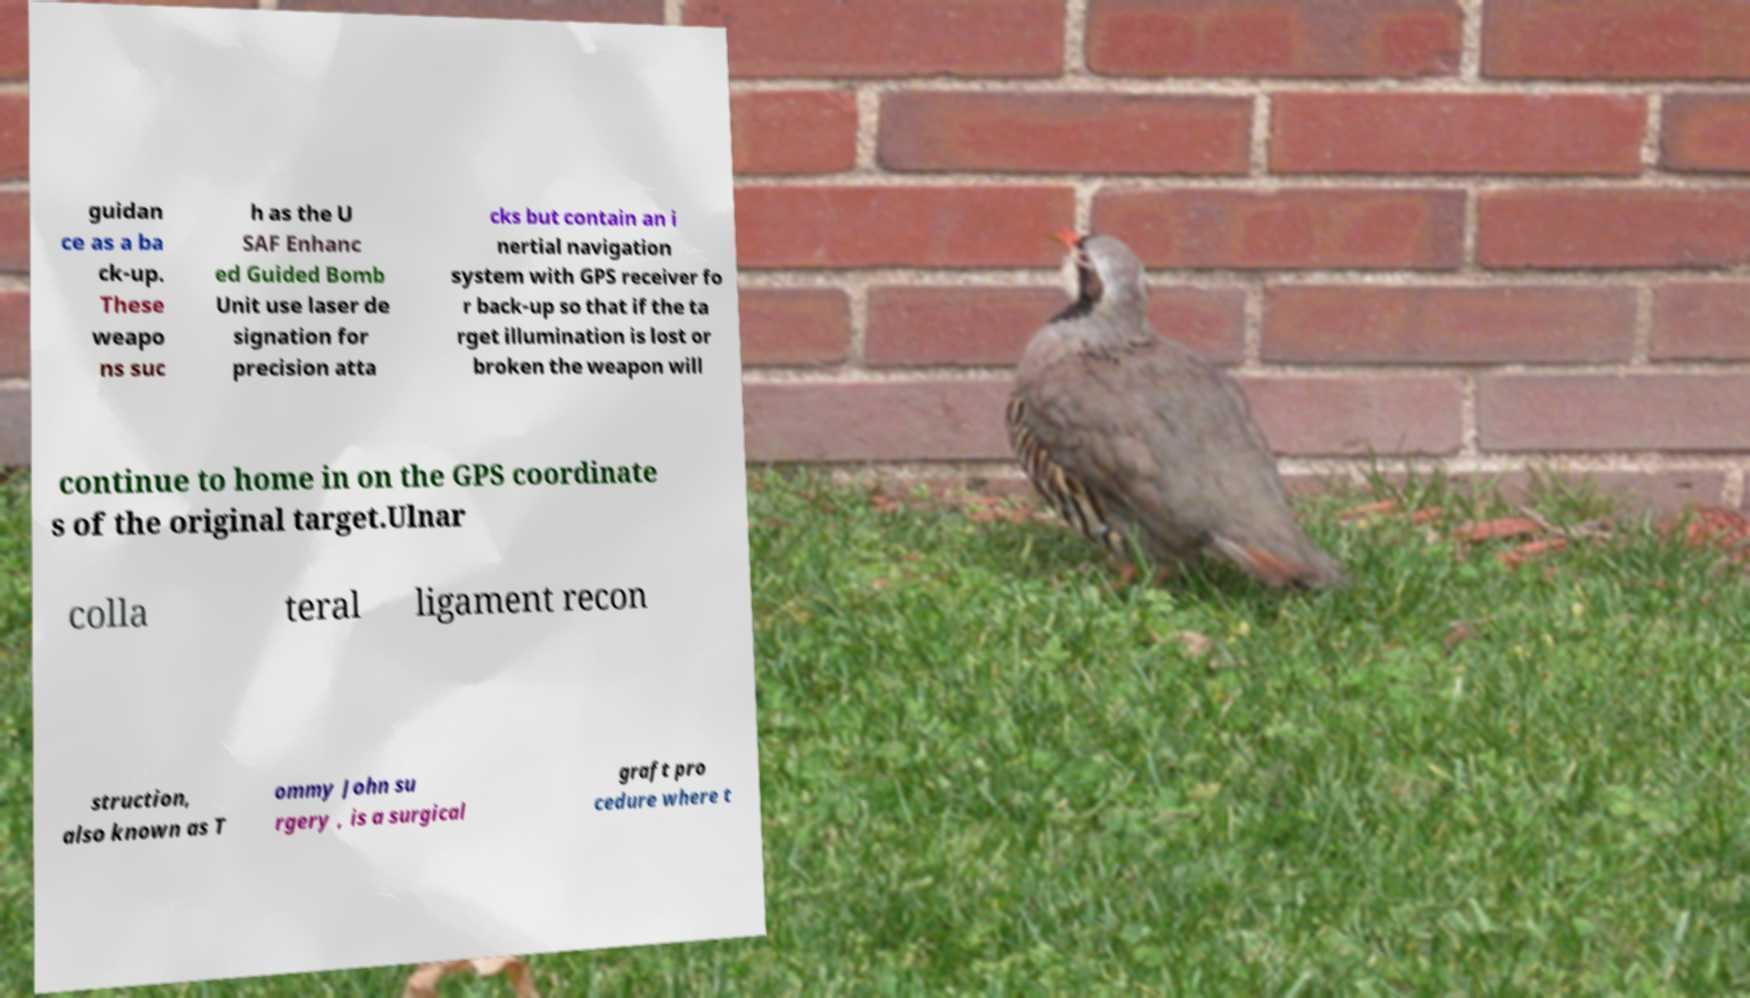Could you extract and type out the text from this image? guidan ce as a ba ck-up. These weapo ns suc h as the U SAF Enhanc ed Guided Bomb Unit use laser de signation for precision atta cks but contain an i nertial navigation system with GPS receiver fo r back-up so that if the ta rget illumination is lost or broken the weapon will continue to home in on the GPS coordinate s of the original target.Ulnar colla teral ligament recon struction, also known as T ommy John su rgery , is a surgical graft pro cedure where t 